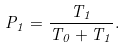Convert formula to latex. <formula><loc_0><loc_0><loc_500><loc_500>P _ { 1 } = \frac { T _ { 1 } } { T _ { 0 } + T _ { 1 } } .</formula> 